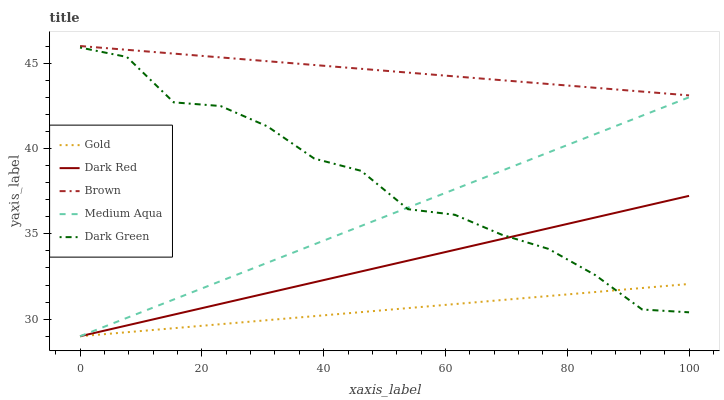Does Gold have the minimum area under the curve?
Answer yes or no. Yes. Does Brown have the maximum area under the curve?
Answer yes or no. Yes. Does Dark Green have the minimum area under the curve?
Answer yes or no. No. Does Dark Green have the maximum area under the curve?
Answer yes or no. No. Is Gold the smoothest?
Answer yes or no. Yes. Is Dark Green the roughest?
Answer yes or no. Yes. Is Medium Aqua the smoothest?
Answer yes or no. No. Is Medium Aqua the roughest?
Answer yes or no. No. Does Dark Red have the lowest value?
Answer yes or no. Yes. Does Dark Green have the lowest value?
Answer yes or no. No. Does Brown have the highest value?
Answer yes or no. Yes. Does Dark Green have the highest value?
Answer yes or no. No. Is Gold less than Brown?
Answer yes or no. Yes. Is Brown greater than Gold?
Answer yes or no. Yes. Does Medium Aqua intersect Dark Green?
Answer yes or no. Yes. Is Medium Aqua less than Dark Green?
Answer yes or no. No. Is Medium Aqua greater than Dark Green?
Answer yes or no. No. Does Gold intersect Brown?
Answer yes or no. No. 